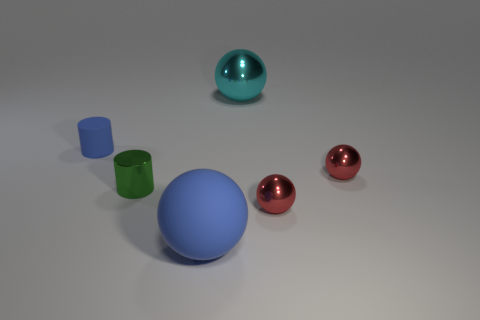Do the green shiny cylinder and the matte cylinder have the same size?
Make the answer very short. Yes. What number of objects are balls to the left of the big cyan metal ball or metal objects?
Your answer should be very brief. 5. There is a green shiny object that is right of the blue matte object that is left of the large blue ball; what is its shape?
Provide a short and direct response. Cylinder. Do the blue ball and the red metal object in front of the green object have the same size?
Provide a short and direct response. No. There is a large object behind the tiny rubber cylinder; what is it made of?
Offer a very short reply. Metal. How many objects are both on the left side of the blue sphere and behind the metallic cylinder?
Offer a very short reply. 1. What is the material of the green cylinder that is the same size as the blue rubber cylinder?
Your answer should be very brief. Metal. There is a matte thing that is to the left of the big rubber object; is its size the same as the blue sphere that is in front of the green shiny cylinder?
Your response must be concise. No. There is a small blue rubber thing; are there any large objects in front of it?
Make the answer very short. Yes. What is the color of the rubber object that is on the right side of the blue matte thing that is behind the small green cylinder?
Ensure brevity in your answer.  Blue. 